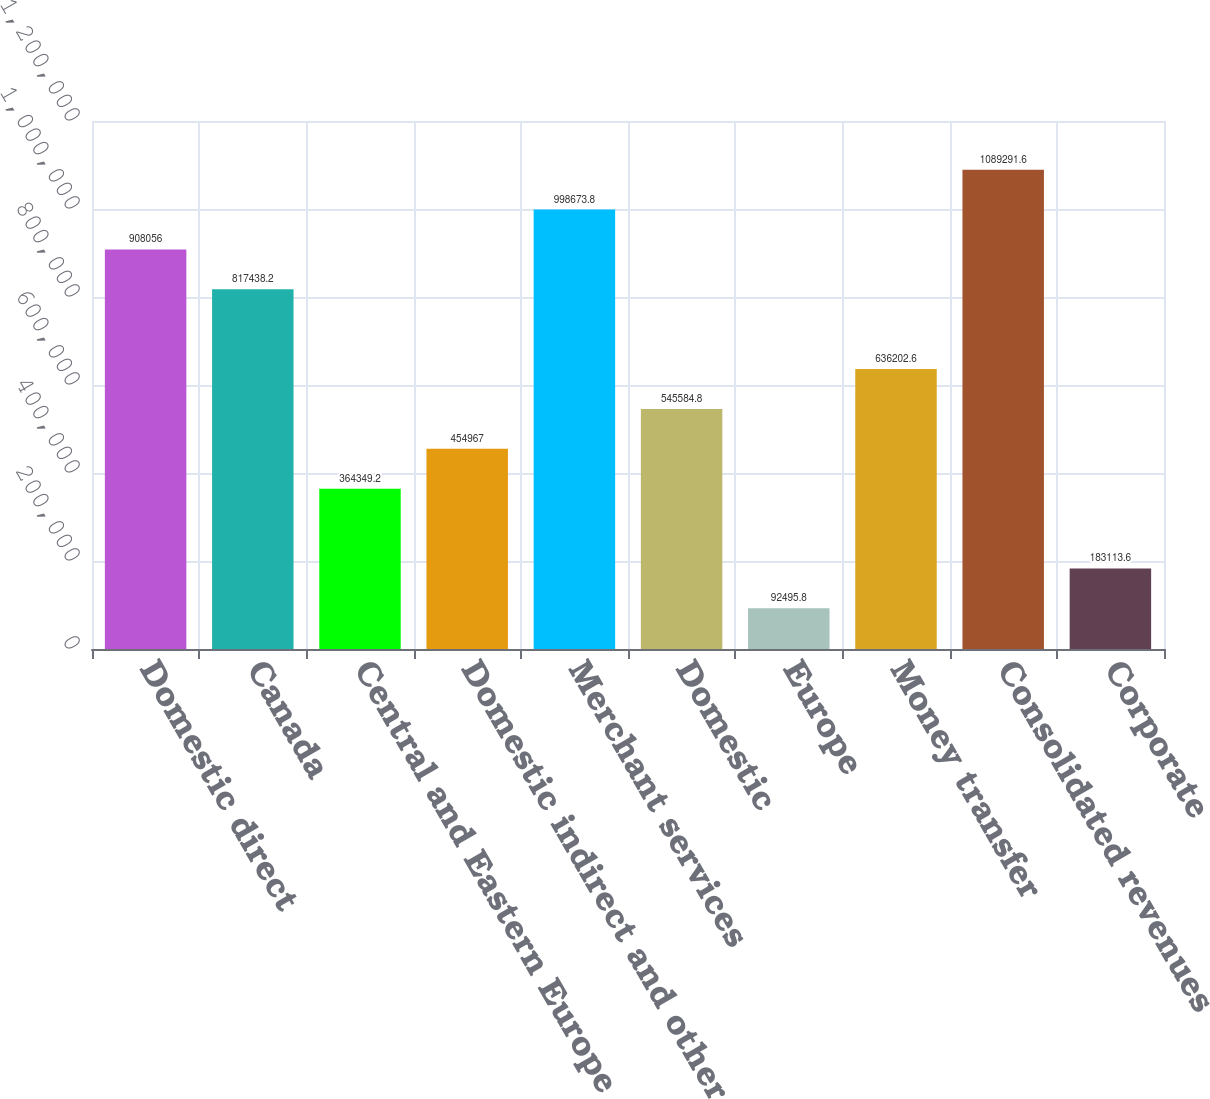Convert chart to OTSL. <chart><loc_0><loc_0><loc_500><loc_500><bar_chart><fcel>Domestic direct<fcel>Canada<fcel>Central and Eastern Europe<fcel>Domestic indirect and other<fcel>Merchant services<fcel>Domestic<fcel>Europe<fcel>Money transfer<fcel>Consolidated revenues<fcel>Corporate<nl><fcel>908056<fcel>817438<fcel>364349<fcel>454967<fcel>998674<fcel>545585<fcel>92495.8<fcel>636203<fcel>1.08929e+06<fcel>183114<nl></chart> 